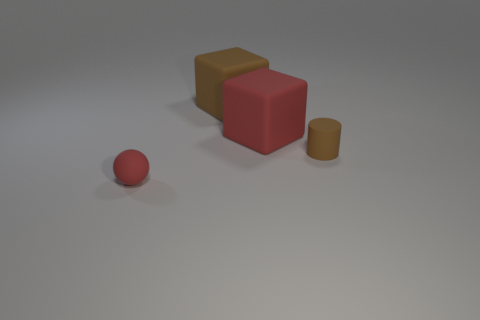Add 3 tiny red matte blocks. How many objects exist? 7 Subtract all spheres. How many objects are left? 3 Subtract 0 cyan blocks. How many objects are left? 4 Subtract all blue cubes. Subtract all red matte things. How many objects are left? 2 Add 4 red spheres. How many red spheres are left? 5 Add 3 brown spheres. How many brown spheres exist? 3 